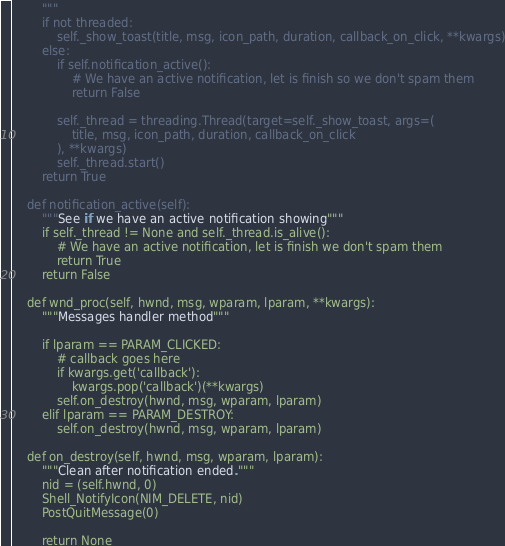<code> <loc_0><loc_0><loc_500><loc_500><_Python_>        """
        if not threaded:
            self._show_toast(title, msg, icon_path, duration, callback_on_click, **kwargs)
        else:
            if self.notification_active():
                # We have an active notification, let is finish so we don't spam them
                return False

            self._thread = threading.Thread(target=self._show_toast, args=(
                title, msg, icon_path, duration, callback_on_click
            ), **kwargs)
            self._thread.start()
        return True

    def notification_active(self):
        """See if we have an active notification showing"""
        if self._thread != None and self._thread.is_alive():
            # We have an active notification, let is finish we don't spam them
            return True
        return False

    def wnd_proc(self, hwnd, msg, wparam, lparam, **kwargs):
        """Messages handler method"""

        if lparam == PARAM_CLICKED:
            # callback goes here
            if kwargs.get('callback'):
                kwargs.pop('callback')(**kwargs)
            self.on_destroy(hwnd, msg, wparam, lparam)
        elif lparam == PARAM_DESTROY:
            self.on_destroy(hwnd, msg, wparam, lparam)

    def on_destroy(self, hwnd, msg, wparam, lparam):
        """Clean after notification ended."""
        nid = (self.hwnd, 0)
        Shell_NotifyIcon(NIM_DELETE, nid)
        PostQuitMessage(0)

        return None</code> 